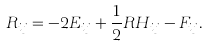<formula> <loc_0><loc_0><loc_500><loc_500>R _ { i j } = - 2 E _ { i j } + \frac { 1 } { 2 } R H _ { i j } - F _ { i j } .</formula> 